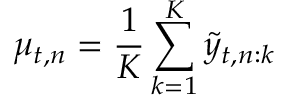Convert formula to latex. <formula><loc_0><loc_0><loc_500><loc_500>\mu _ { t , n } = \frac { 1 } { K } \sum _ { k = 1 } ^ { K } \tilde { y } _ { t , n \colon k }</formula> 